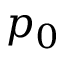<formula> <loc_0><loc_0><loc_500><loc_500>p _ { 0 }</formula> 